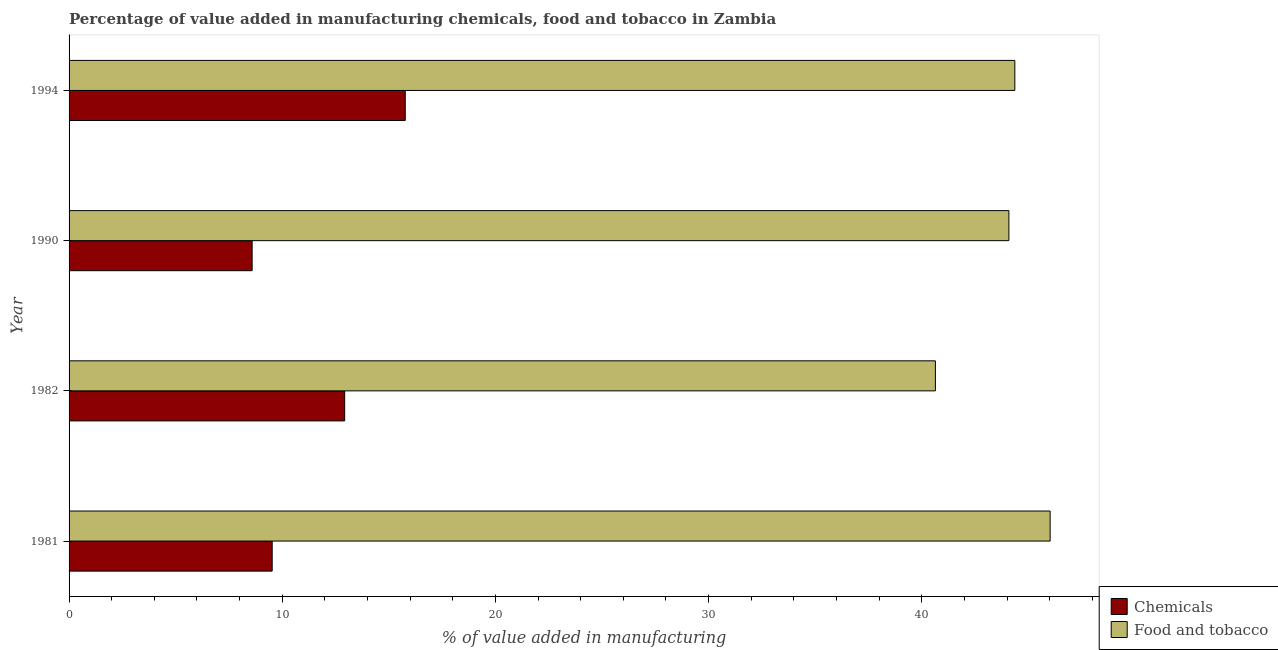How many different coloured bars are there?
Ensure brevity in your answer.  2. Are the number of bars on each tick of the Y-axis equal?
Make the answer very short. Yes. What is the value added by manufacturing food and tobacco in 1994?
Offer a terse response. 44.37. Across all years, what is the maximum value added by manufacturing food and tobacco?
Your answer should be very brief. 46.02. Across all years, what is the minimum value added by manufacturing food and tobacco?
Keep it short and to the point. 40.64. In which year was the value added by manufacturing food and tobacco maximum?
Offer a terse response. 1981. In which year was the value added by  manufacturing chemicals minimum?
Make the answer very short. 1990. What is the total value added by  manufacturing chemicals in the graph?
Give a very brief answer. 46.81. What is the difference between the value added by manufacturing food and tobacco in 1990 and that in 1994?
Your answer should be very brief. -0.28. What is the difference between the value added by  manufacturing chemicals in 1982 and the value added by manufacturing food and tobacco in 1994?
Keep it short and to the point. -31.44. What is the average value added by manufacturing food and tobacco per year?
Ensure brevity in your answer.  43.78. In the year 1982, what is the difference between the value added by  manufacturing chemicals and value added by manufacturing food and tobacco?
Ensure brevity in your answer.  -27.71. What is the ratio of the value added by manufacturing food and tobacco in 1990 to that in 1994?
Your response must be concise. 0.99. What is the difference between the highest and the second highest value added by manufacturing food and tobacco?
Your answer should be very brief. 1.66. What is the difference between the highest and the lowest value added by  manufacturing chemicals?
Provide a short and direct response. 7.18. Is the sum of the value added by  manufacturing chemicals in 1981 and 1982 greater than the maximum value added by manufacturing food and tobacco across all years?
Your answer should be very brief. No. What does the 2nd bar from the top in 1981 represents?
Offer a very short reply. Chemicals. What does the 1st bar from the bottom in 1990 represents?
Offer a very short reply. Chemicals. Are all the bars in the graph horizontal?
Provide a succinct answer. Yes. How many years are there in the graph?
Your answer should be very brief. 4. Does the graph contain any zero values?
Offer a terse response. No. Does the graph contain grids?
Keep it short and to the point. No. Where does the legend appear in the graph?
Ensure brevity in your answer.  Bottom right. What is the title of the graph?
Offer a terse response. Percentage of value added in manufacturing chemicals, food and tobacco in Zambia. What is the label or title of the X-axis?
Provide a short and direct response. % of value added in manufacturing. What is the % of value added in manufacturing of Chemicals in 1981?
Offer a terse response. 9.53. What is the % of value added in manufacturing in Food and tobacco in 1981?
Your answer should be very brief. 46.02. What is the % of value added in manufacturing in Chemicals in 1982?
Provide a short and direct response. 12.93. What is the % of value added in manufacturing of Food and tobacco in 1982?
Your response must be concise. 40.64. What is the % of value added in manufacturing in Chemicals in 1990?
Provide a succinct answer. 8.59. What is the % of value added in manufacturing in Food and tobacco in 1990?
Ensure brevity in your answer.  44.09. What is the % of value added in manufacturing of Chemicals in 1994?
Your answer should be very brief. 15.77. What is the % of value added in manufacturing of Food and tobacco in 1994?
Offer a very short reply. 44.37. Across all years, what is the maximum % of value added in manufacturing in Chemicals?
Provide a succinct answer. 15.77. Across all years, what is the maximum % of value added in manufacturing in Food and tobacco?
Make the answer very short. 46.02. Across all years, what is the minimum % of value added in manufacturing in Chemicals?
Your answer should be very brief. 8.59. Across all years, what is the minimum % of value added in manufacturing of Food and tobacco?
Offer a very short reply. 40.64. What is the total % of value added in manufacturing in Chemicals in the graph?
Offer a terse response. 46.81. What is the total % of value added in manufacturing of Food and tobacco in the graph?
Your response must be concise. 175.12. What is the difference between the % of value added in manufacturing in Chemicals in 1981 and that in 1982?
Ensure brevity in your answer.  -3.4. What is the difference between the % of value added in manufacturing in Food and tobacco in 1981 and that in 1982?
Offer a very short reply. 5.38. What is the difference between the % of value added in manufacturing of Chemicals in 1981 and that in 1990?
Your response must be concise. 0.94. What is the difference between the % of value added in manufacturing of Food and tobacco in 1981 and that in 1990?
Your answer should be very brief. 1.94. What is the difference between the % of value added in manufacturing in Chemicals in 1981 and that in 1994?
Offer a very short reply. -6.24. What is the difference between the % of value added in manufacturing in Food and tobacco in 1981 and that in 1994?
Keep it short and to the point. 1.66. What is the difference between the % of value added in manufacturing in Chemicals in 1982 and that in 1990?
Ensure brevity in your answer.  4.34. What is the difference between the % of value added in manufacturing in Food and tobacco in 1982 and that in 1990?
Offer a very short reply. -3.45. What is the difference between the % of value added in manufacturing of Chemicals in 1982 and that in 1994?
Give a very brief answer. -2.84. What is the difference between the % of value added in manufacturing in Food and tobacco in 1982 and that in 1994?
Provide a succinct answer. -3.73. What is the difference between the % of value added in manufacturing in Chemicals in 1990 and that in 1994?
Offer a terse response. -7.18. What is the difference between the % of value added in manufacturing of Food and tobacco in 1990 and that in 1994?
Provide a succinct answer. -0.28. What is the difference between the % of value added in manufacturing of Chemicals in 1981 and the % of value added in manufacturing of Food and tobacco in 1982?
Make the answer very short. -31.11. What is the difference between the % of value added in manufacturing in Chemicals in 1981 and the % of value added in manufacturing in Food and tobacco in 1990?
Make the answer very short. -34.56. What is the difference between the % of value added in manufacturing in Chemicals in 1981 and the % of value added in manufacturing in Food and tobacco in 1994?
Offer a terse response. -34.84. What is the difference between the % of value added in manufacturing of Chemicals in 1982 and the % of value added in manufacturing of Food and tobacco in 1990?
Offer a terse response. -31.16. What is the difference between the % of value added in manufacturing of Chemicals in 1982 and the % of value added in manufacturing of Food and tobacco in 1994?
Your answer should be very brief. -31.44. What is the difference between the % of value added in manufacturing of Chemicals in 1990 and the % of value added in manufacturing of Food and tobacco in 1994?
Offer a terse response. -35.78. What is the average % of value added in manufacturing of Chemicals per year?
Your answer should be compact. 11.7. What is the average % of value added in manufacturing in Food and tobacco per year?
Offer a terse response. 43.78. In the year 1981, what is the difference between the % of value added in manufacturing of Chemicals and % of value added in manufacturing of Food and tobacco?
Make the answer very short. -36.49. In the year 1982, what is the difference between the % of value added in manufacturing of Chemicals and % of value added in manufacturing of Food and tobacco?
Offer a terse response. -27.71. In the year 1990, what is the difference between the % of value added in manufacturing in Chemicals and % of value added in manufacturing in Food and tobacco?
Keep it short and to the point. -35.5. In the year 1994, what is the difference between the % of value added in manufacturing in Chemicals and % of value added in manufacturing in Food and tobacco?
Your answer should be compact. -28.6. What is the ratio of the % of value added in manufacturing of Chemicals in 1981 to that in 1982?
Give a very brief answer. 0.74. What is the ratio of the % of value added in manufacturing in Food and tobacco in 1981 to that in 1982?
Make the answer very short. 1.13. What is the ratio of the % of value added in manufacturing in Chemicals in 1981 to that in 1990?
Offer a very short reply. 1.11. What is the ratio of the % of value added in manufacturing in Food and tobacco in 1981 to that in 1990?
Ensure brevity in your answer.  1.04. What is the ratio of the % of value added in manufacturing of Chemicals in 1981 to that in 1994?
Your answer should be very brief. 0.6. What is the ratio of the % of value added in manufacturing of Food and tobacco in 1981 to that in 1994?
Offer a very short reply. 1.04. What is the ratio of the % of value added in manufacturing of Chemicals in 1982 to that in 1990?
Provide a short and direct response. 1.51. What is the ratio of the % of value added in manufacturing of Food and tobacco in 1982 to that in 1990?
Keep it short and to the point. 0.92. What is the ratio of the % of value added in manufacturing of Chemicals in 1982 to that in 1994?
Keep it short and to the point. 0.82. What is the ratio of the % of value added in manufacturing of Food and tobacco in 1982 to that in 1994?
Ensure brevity in your answer.  0.92. What is the ratio of the % of value added in manufacturing in Chemicals in 1990 to that in 1994?
Ensure brevity in your answer.  0.54. What is the ratio of the % of value added in manufacturing in Food and tobacco in 1990 to that in 1994?
Provide a succinct answer. 0.99. What is the difference between the highest and the second highest % of value added in manufacturing in Chemicals?
Provide a short and direct response. 2.84. What is the difference between the highest and the second highest % of value added in manufacturing in Food and tobacco?
Give a very brief answer. 1.66. What is the difference between the highest and the lowest % of value added in manufacturing of Chemicals?
Make the answer very short. 7.18. What is the difference between the highest and the lowest % of value added in manufacturing of Food and tobacco?
Provide a succinct answer. 5.38. 